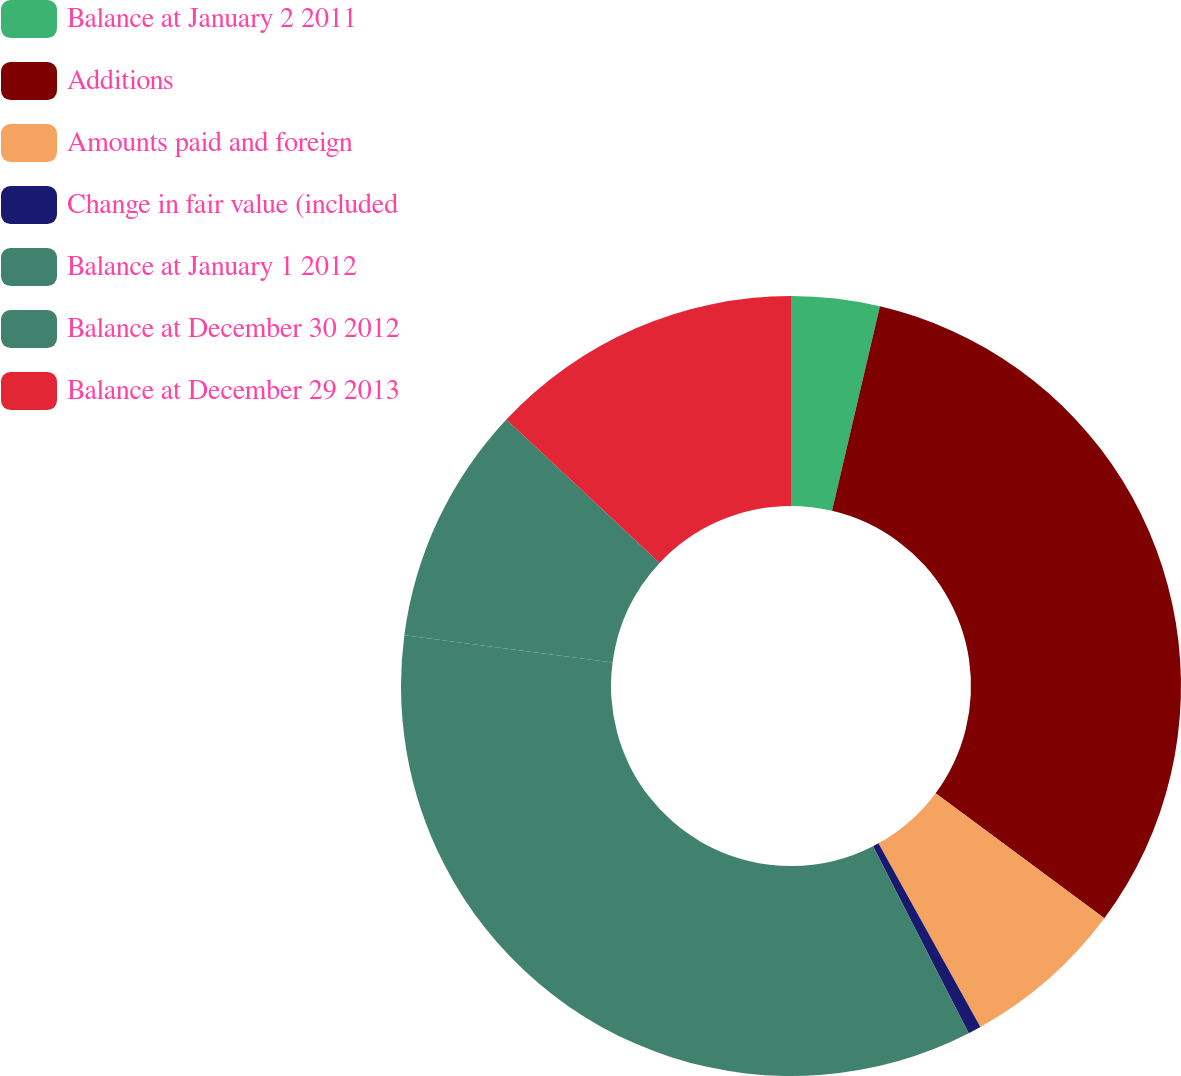Convert chart. <chart><loc_0><loc_0><loc_500><loc_500><pie_chart><fcel>Balance at January 2 2011<fcel>Additions<fcel>Amounts paid and foreign<fcel>Change in fair value (included<fcel>Balance at January 1 2012<fcel>Balance at December 30 2012<fcel>Balance at December 29 2013<nl><fcel>3.66%<fcel>31.49%<fcel>6.78%<fcel>0.54%<fcel>34.61%<fcel>9.9%<fcel>13.02%<nl></chart> 